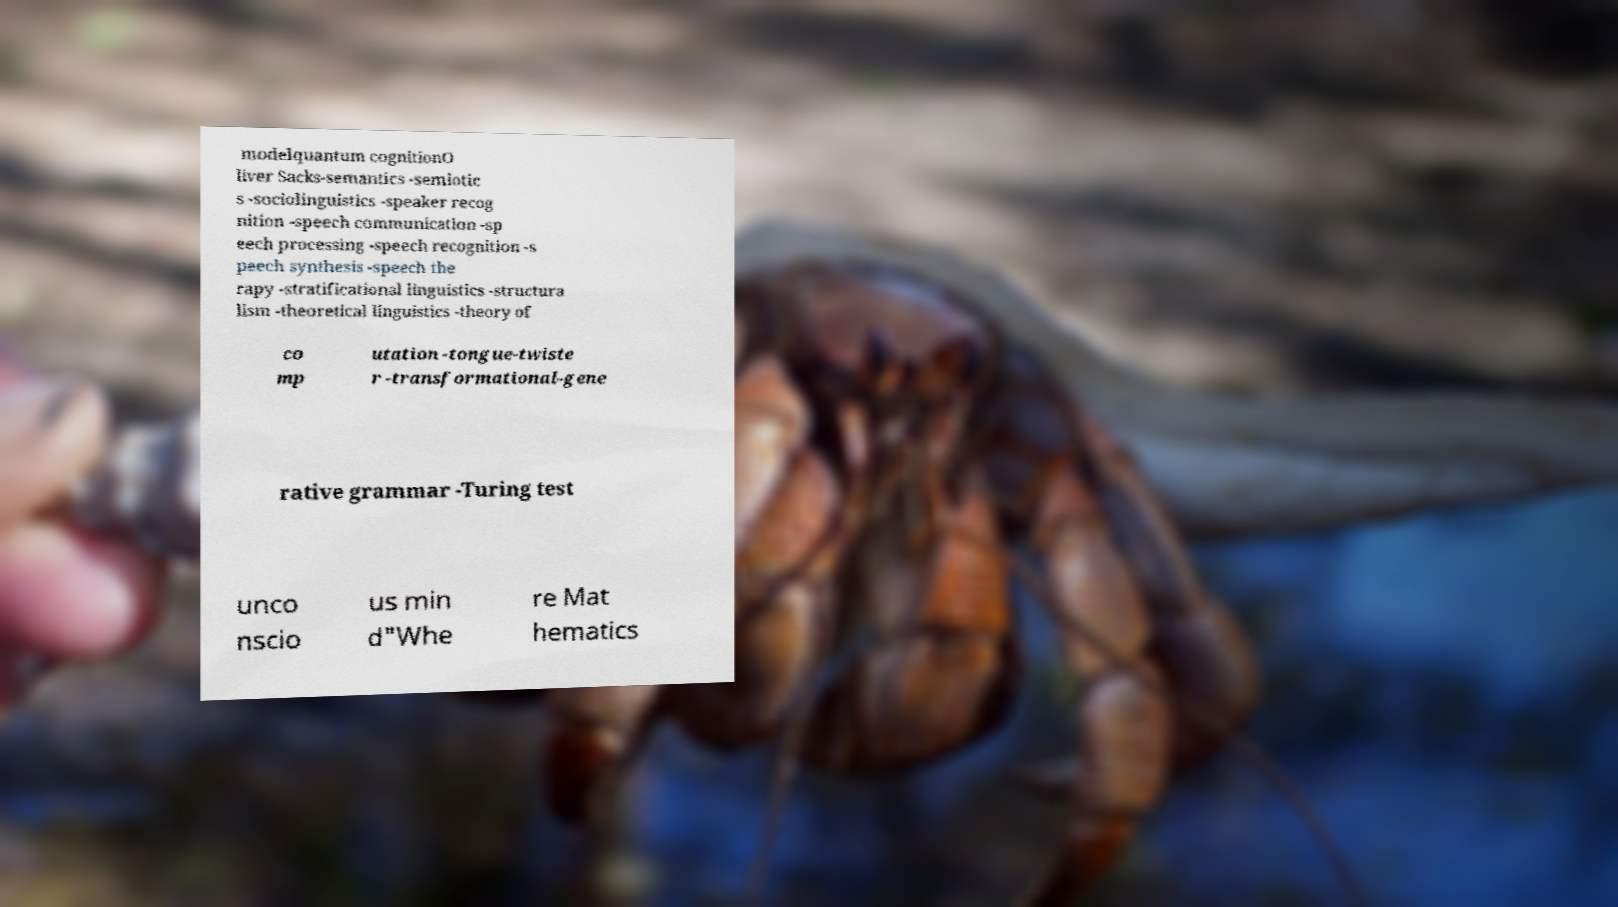Can you accurately transcribe the text from the provided image for me? modelquantum cognitionO liver Sacks-semantics -semiotic s -sociolinguistics -speaker recog nition -speech communication -sp eech processing -speech recognition -s peech synthesis -speech the rapy -stratificational linguistics -structura lism -theoretical linguistics -theory of co mp utation -tongue-twiste r -transformational-gene rative grammar -Turing test unco nscio us min d"Whe re Mat hematics 